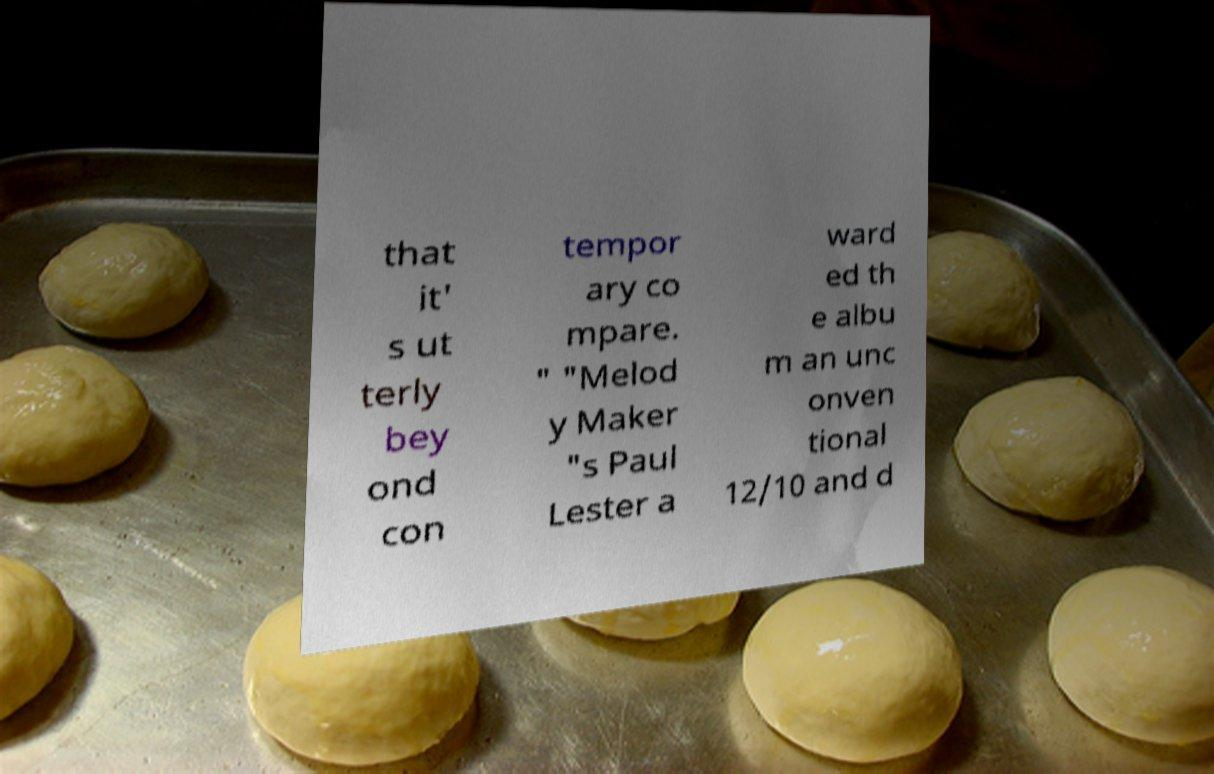For documentation purposes, I need the text within this image transcribed. Could you provide that? that it' s ut terly bey ond con tempor ary co mpare. " "Melod y Maker "s Paul Lester a ward ed th e albu m an unc onven tional 12/10 and d 